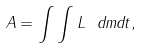<formula> <loc_0><loc_0><loc_500><loc_500>A = \int \int L \ d m d t ,</formula> 